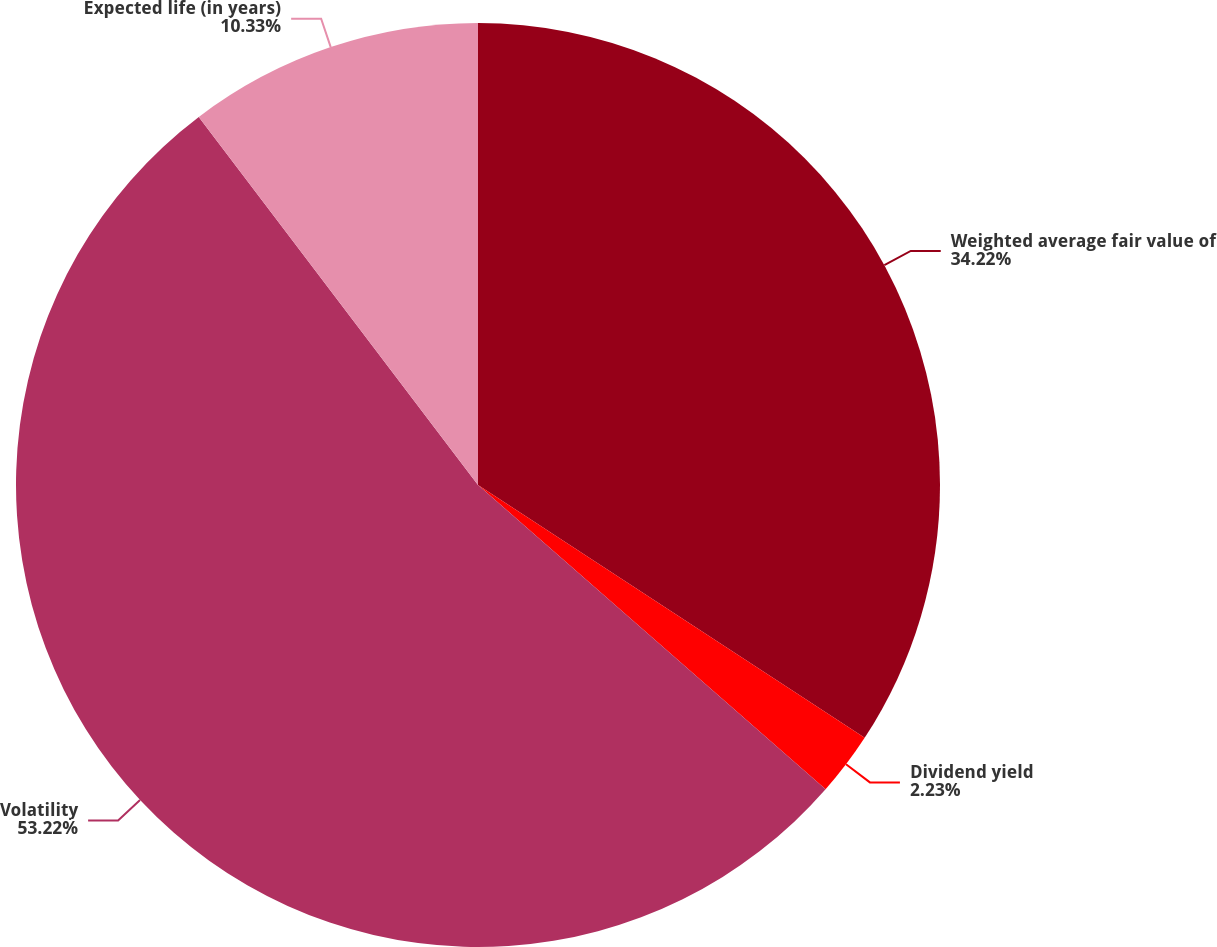Convert chart. <chart><loc_0><loc_0><loc_500><loc_500><pie_chart><fcel>Weighted average fair value of<fcel>Dividend yield<fcel>Volatility<fcel>Expected life (in years)<nl><fcel>34.22%<fcel>2.23%<fcel>53.23%<fcel>10.33%<nl></chart> 